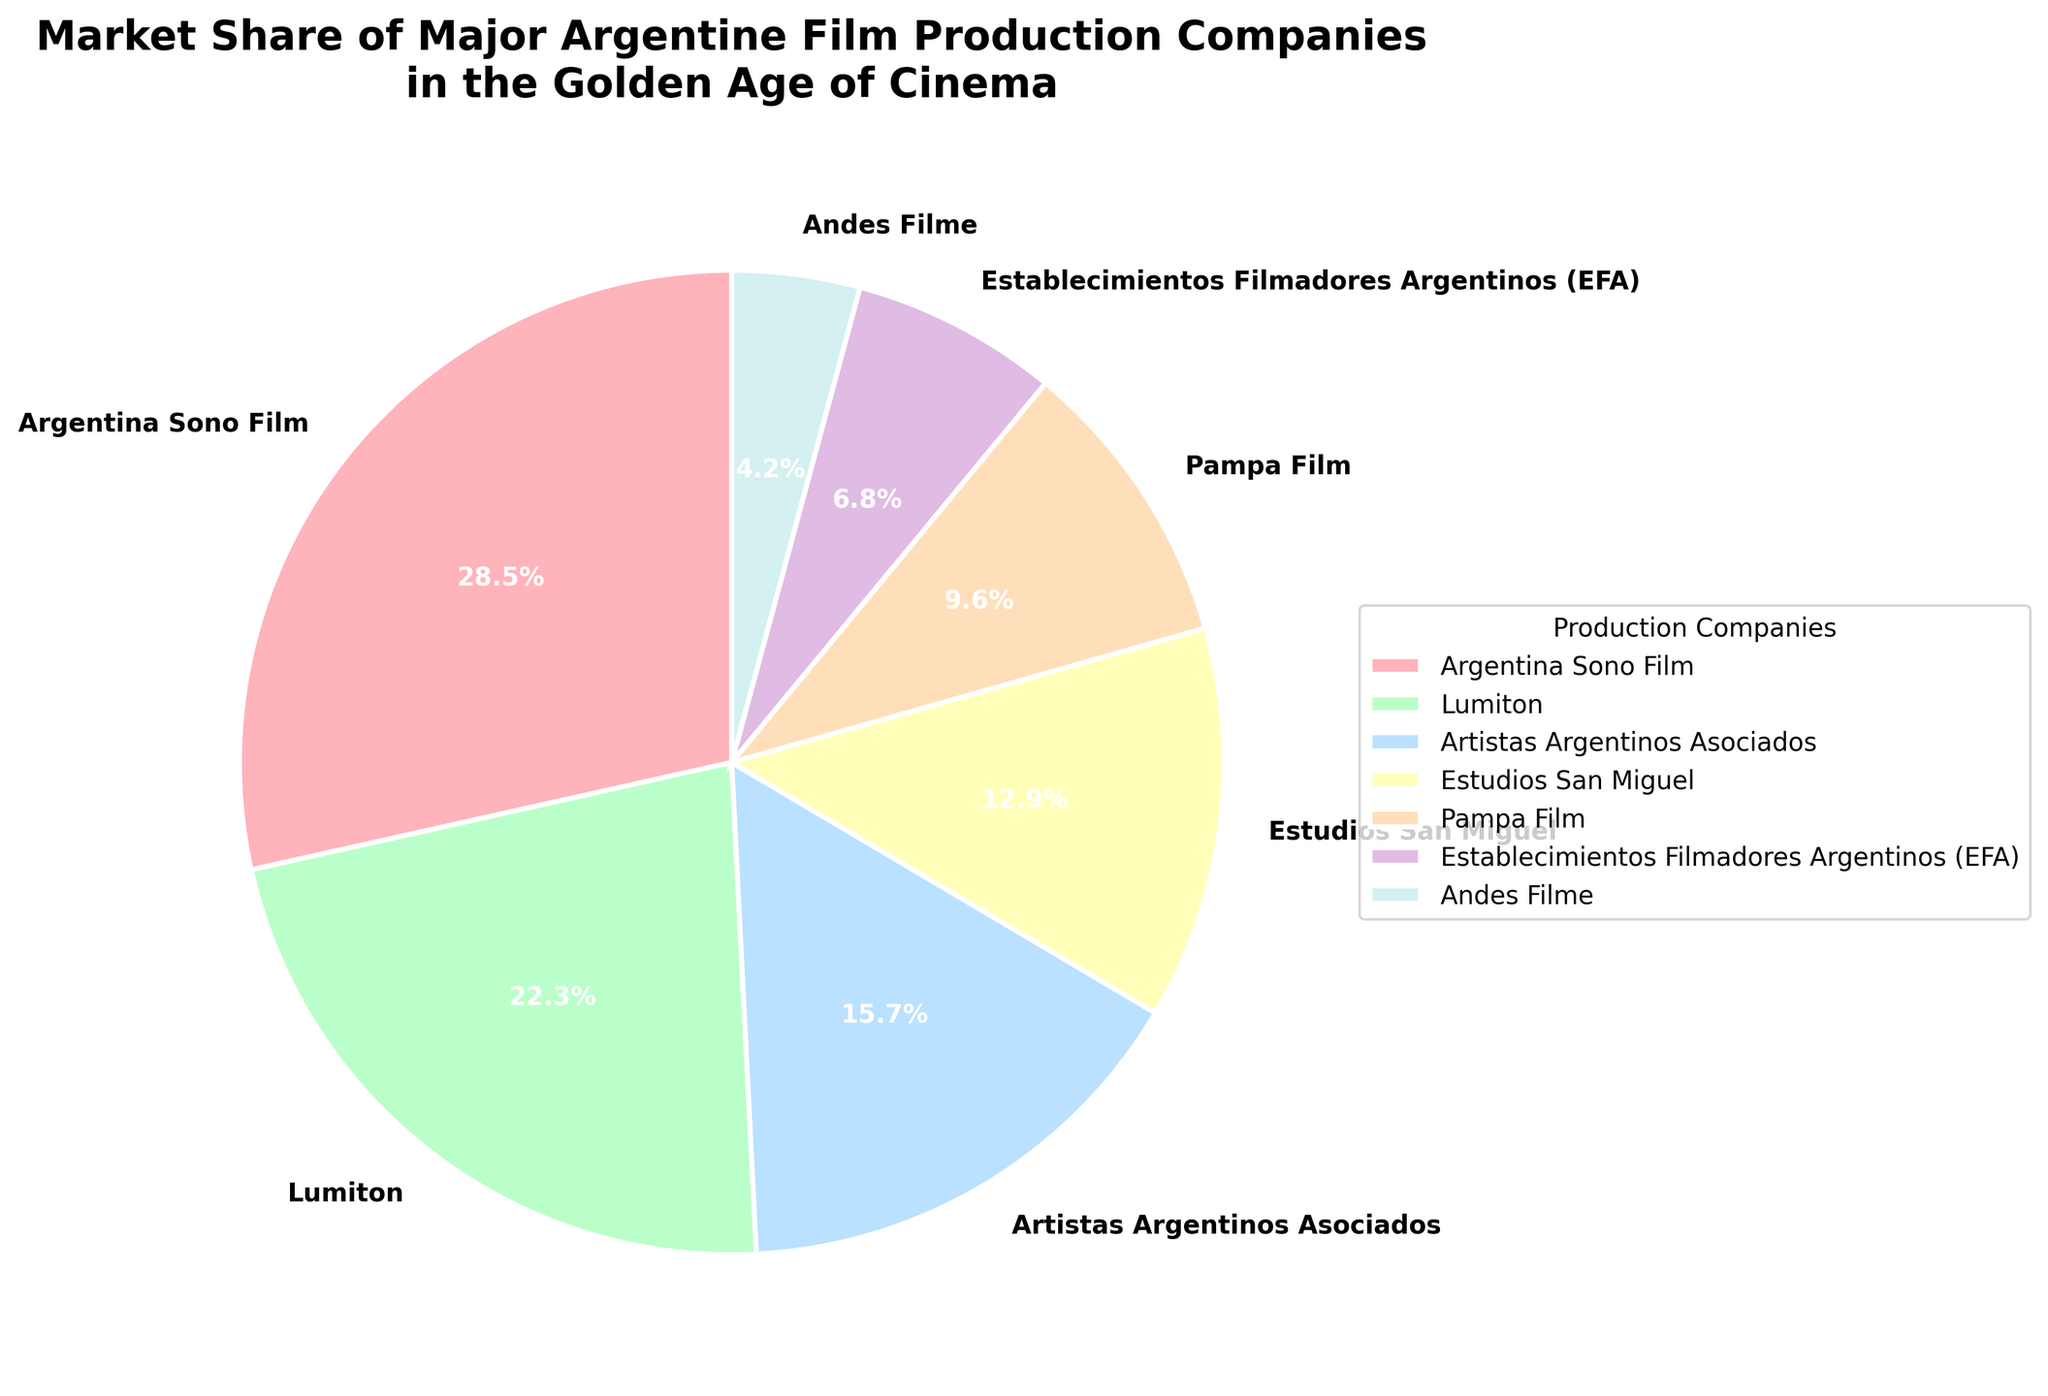Which company has the highest market share? The slice representing Argentina Sono Film stands out as the largest, with a market share of 28.5%.
Answer: Argentina Sono Film Which two companies together control more than half of the market? Adding the market shares of Argentina Sono Film (28.5%) and Lumiton (22.3%), we get 28.5% + 22.3% = 50.8%, which is more than half of the market.
Answer: Argentina Sono Film and Lumiton Which company has a smaller market share, Pampa Film or Estudios San Miguel? Comparing the slices, Pampa Film has a market share of 9.6%, and Estudios San Miguel has 12.9%. Therefore, Pampa Film has a smaller market share.
Answer: Pampa Film What's the total market share of the top three companies? Summing the market shares of the top three companies: Argentina Sono Film (28.5%), Lumiton (22.3%), and Artistas Argentinos Asociados (15.7%), we get 28.5% + 22.3% + 15.7% = 66.5%.
Answer: 66.5% By how much does the market share of Estudios San Miguel differ from that of Artistas Argentinos Asociados? The market share of Artistas Argentinos Asociados is 15.7%, and for Estudios San Miguel, it is 12.9%. The difference is 15.7% - 12.9% = 2.8%.
Answer: 2.8% Which company has a market share greater than Andina Filme but less than Pampa Film? Comparing the slices, Establecimientos Filmadores Argentinos (EFA) has a market share of 6.8%, which is more than Andes Filme (4.2%) but less than Pampa Film (9.6%).
Answer: Establecimientos Filmadores Argentinos (EFA) What is the combined market share of the companies with less than 10% each? Adding the market shares of Pampa Film (9.6%), Establecimientos Filmadores Argentinos (EFA) (6.8%), and Andes Filme (4.2%): 9.6% + 6.8% + 4.2% = 20.6%.
Answer: 20.6% Which company's segment is visually represented in a light blue color? The segment colored in light blue corresponds to Estudios San Miguel, with a market share of 12.9%.
Answer: Estudios San Miguel If another company were added to the chart with a market share of 5%, how would this compare to Andes Filme's market share? Comparing 5% to Andes Filme's market share of 4.2%, the new company's market share would be larger.
Answer: It would be larger 